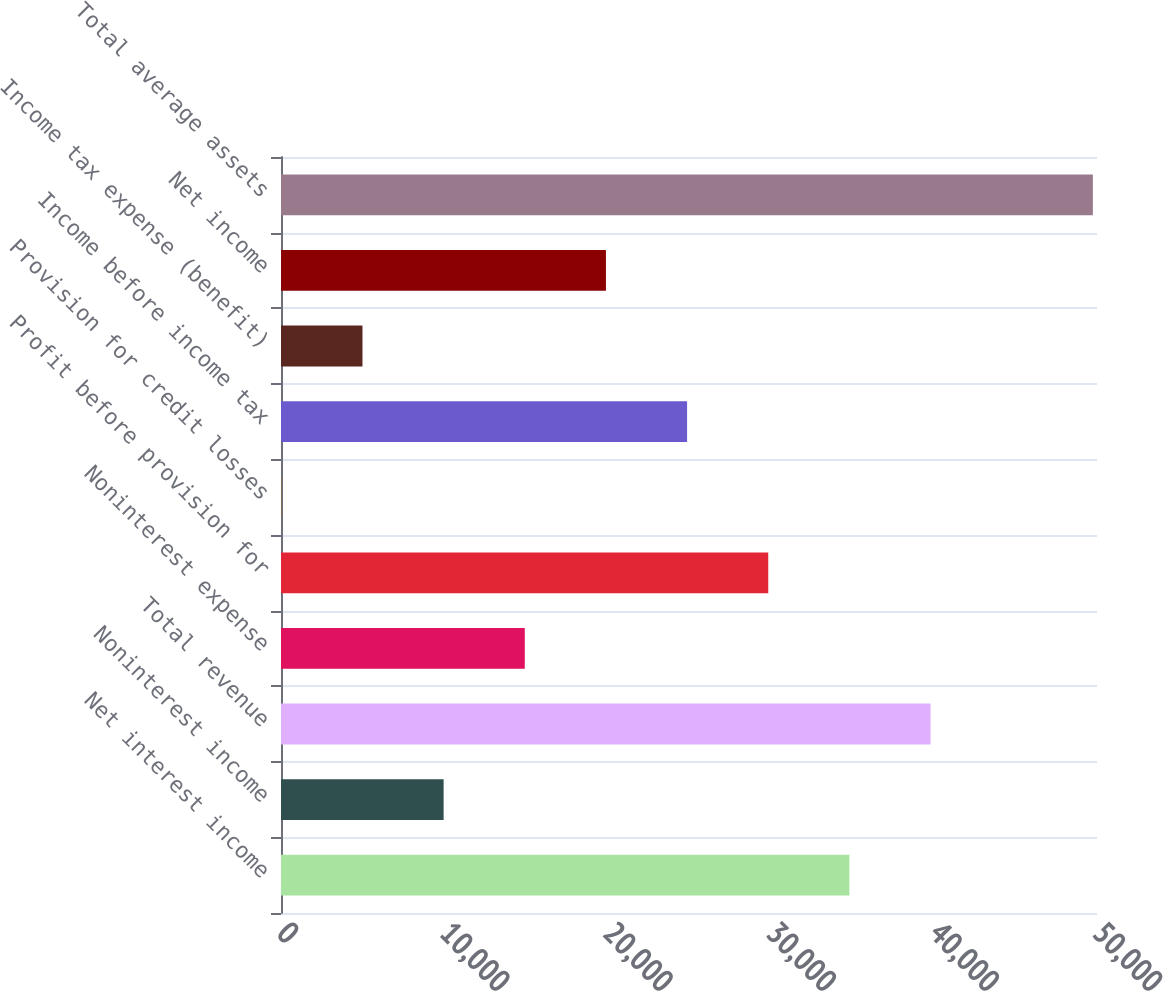Convert chart to OTSL. <chart><loc_0><loc_0><loc_500><loc_500><bar_chart><fcel>Net interest income<fcel>Noninterest income<fcel>Total revenue<fcel>Noninterest expense<fcel>Profit before provision for<fcel>Provision for credit losses<fcel>Income before income tax<fcel>Income tax expense (benefit)<fcel>Net income<fcel>Total average assets<nl><fcel>34828.6<fcel>9964.6<fcel>39801.4<fcel>14937.4<fcel>29855.8<fcel>19<fcel>24883<fcel>4991.8<fcel>19910.2<fcel>49747<nl></chart> 